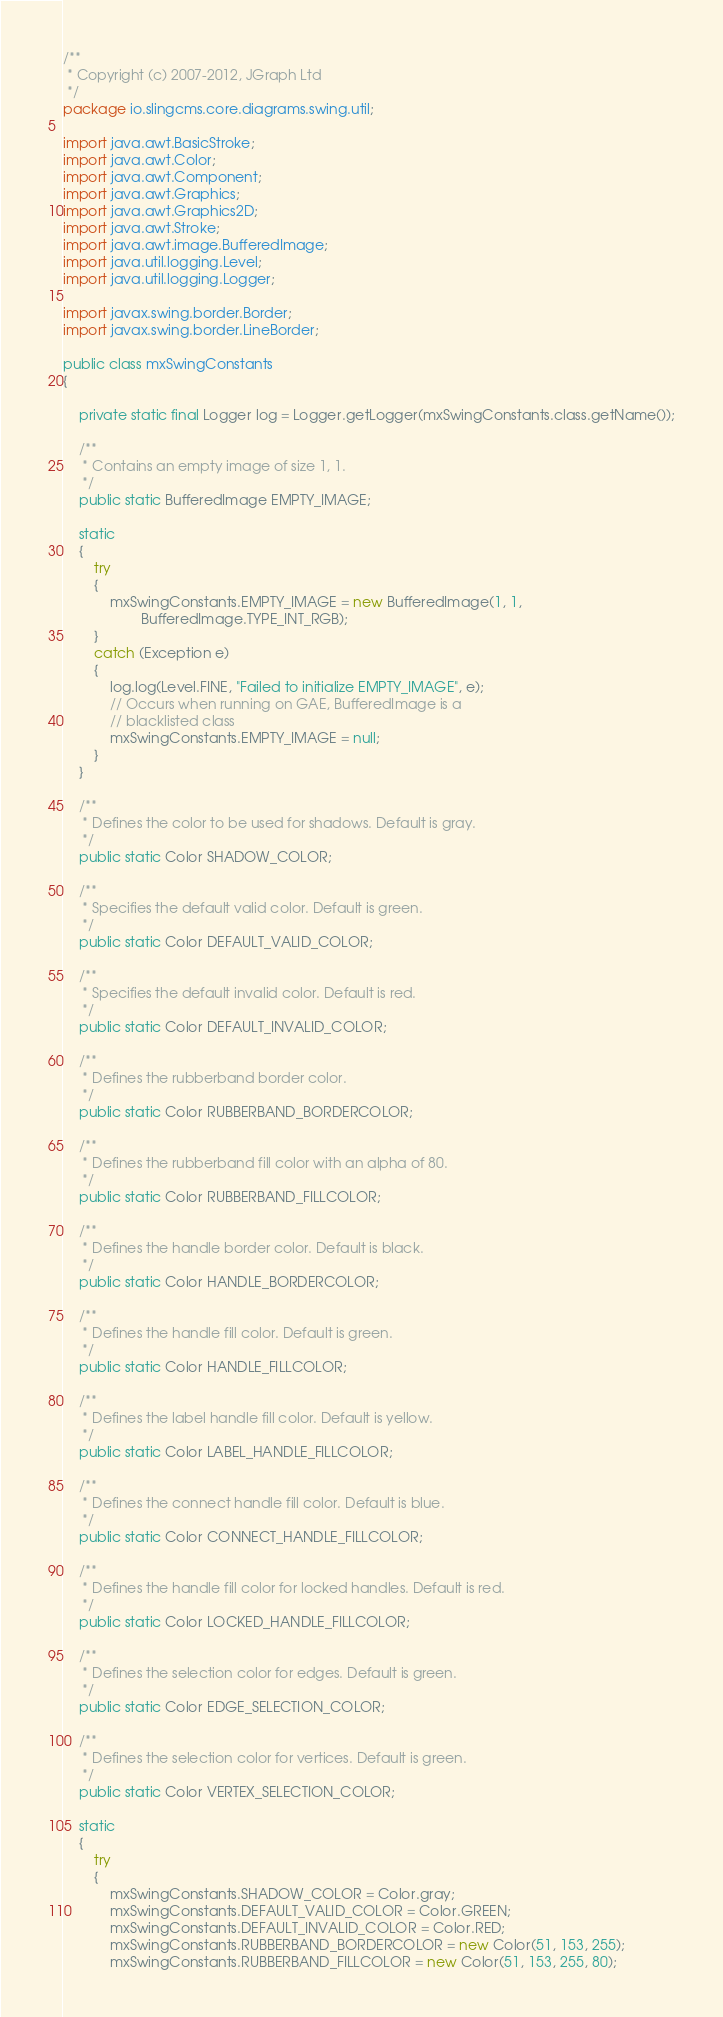<code> <loc_0><loc_0><loc_500><loc_500><_Java_>/**
 * Copyright (c) 2007-2012, JGraph Ltd
 */
package io.slingcms.core.diagrams.swing.util;

import java.awt.BasicStroke;
import java.awt.Color;
import java.awt.Component;
import java.awt.Graphics;
import java.awt.Graphics2D;
import java.awt.Stroke;
import java.awt.image.BufferedImage;
import java.util.logging.Level;
import java.util.logging.Logger;

import javax.swing.border.Border;
import javax.swing.border.LineBorder;

public class mxSwingConstants
{

	private static final Logger log = Logger.getLogger(mxSwingConstants.class.getName());

	/**
	 * Contains an empty image of size 1, 1.
	 */
	public static BufferedImage EMPTY_IMAGE;

	static
	{
		try
		{
			mxSwingConstants.EMPTY_IMAGE = new BufferedImage(1, 1,
					BufferedImage.TYPE_INT_RGB);
		}
		catch (Exception e)
		{
			log.log(Level.FINE, "Failed to initialize EMPTY_IMAGE", e);
			// Occurs when running on GAE, BufferedImage is a
			// blacklisted class
			mxSwingConstants.EMPTY_IMAGE = null;
		}
	}
	
	/**
	 * Defines the color to be used for shadows. Default is gray.
	 */
	public static Color SHADOW_COLOR;
	
	/**
	 * Specifies the default valid color. Default is green.
	 */
	public static Color DEFAULT_VALID_COLOR;

	/**
	 * Specifies the default invalid color. Default is red.
	 */
	public static Color DEFAULT_INVALID_COLOR;
	
	/**
	 * Defines the rubberband border color. 
	 */
	public static Color RUBBERBAND_BORDERCOLOR;

	/**
	 * Defines the rubberband fill color with an alpha of 80.
	 */
	public static Color RUBBERBAND_FILLCOLOR;
	
	/**
	 * Defines the handle border color. Default is black.
	 */
	public static Color HANDLE_BORDERCOLOR;

	/**
	 * Defines the handle fill color. Default is green.
	 */
	public static Color HANDLE_FILLCOLOR;

	/**
	 * Defines the label handle fill color. Default is yellow.
	 */
	public static Color LABEL_HANDLE_FILLCOLOR;

	/**
	 * Defines the connect handle fill color. Default is blue.
	 */
	public static Color CONNECT_HANDLE_FILLCOLOR;

	/**
	 * Defines the handle fill color for locked handles. Default is red.
	 */
	public static Color LOCKED_HANDLE_FILLCOLOR;
	
	/**
	 * Defines the selection color for edges. Default is green.
	 */
	public static Color EDGE_SELECTION_COLOR;

	/**
	 * Defines the selection color for vertices. Default is green.
	 */
	public static Color VERTEX_SELECTION_COLOR;
	
	static
	{
		try
		{
			mxSwingConstants.SHADOW_COLOR = Color.gray;
			mxSwingConstants.DEFAULT_VALID_COLOR = Color.GREEN;
			mxSwingConstants.DEFAULT_INVALID_COLOR = Color.RED;
			mxSwingConstants.RUBBERBAND_BORDERCOLOR = new Color(51, 153, 255);
			mxSwingConstants.RUBBERBAND_FILLCOLOR = new Color(51, 153, 255, 80);</code> 